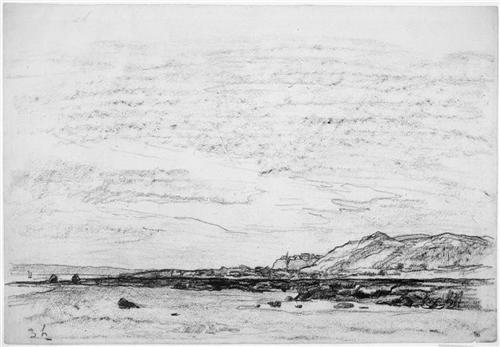What is this photo about? The image is a black and white sketch capturing a serene, possibly coastal landscape with an impressionistic style emphasizing texture and spontaneous line work. The foreground features a rugged shoreline, interspersed with boulders, leading the viewer's eyes toward a dramatic mountain range in the background. Beyond its artistic qualities, the sketch might suggest deeper themes such as the enduring power of nature or a quiet moment of solitude. The use of monochrome enhances the play between light and shadow, lending the scene a timeless quality that might evoke contemplation or introspection in the viewer. 